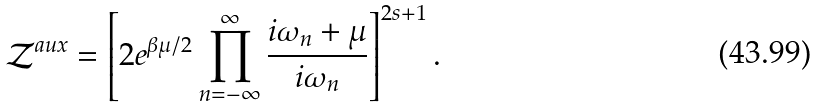<formula> <loc_0><loc_0><loc_500><loc_500>\mathcal { Z } ^ { a u x } = \left [ 2 e ^ { \beta \mu / 2 } \prod _ { n = - \infty } ^ { \infty } \frac { i \omega _ { n } + \mu } { i \omega _ { n } } \right ] ^ { 2 s + 1 } .</formula> 